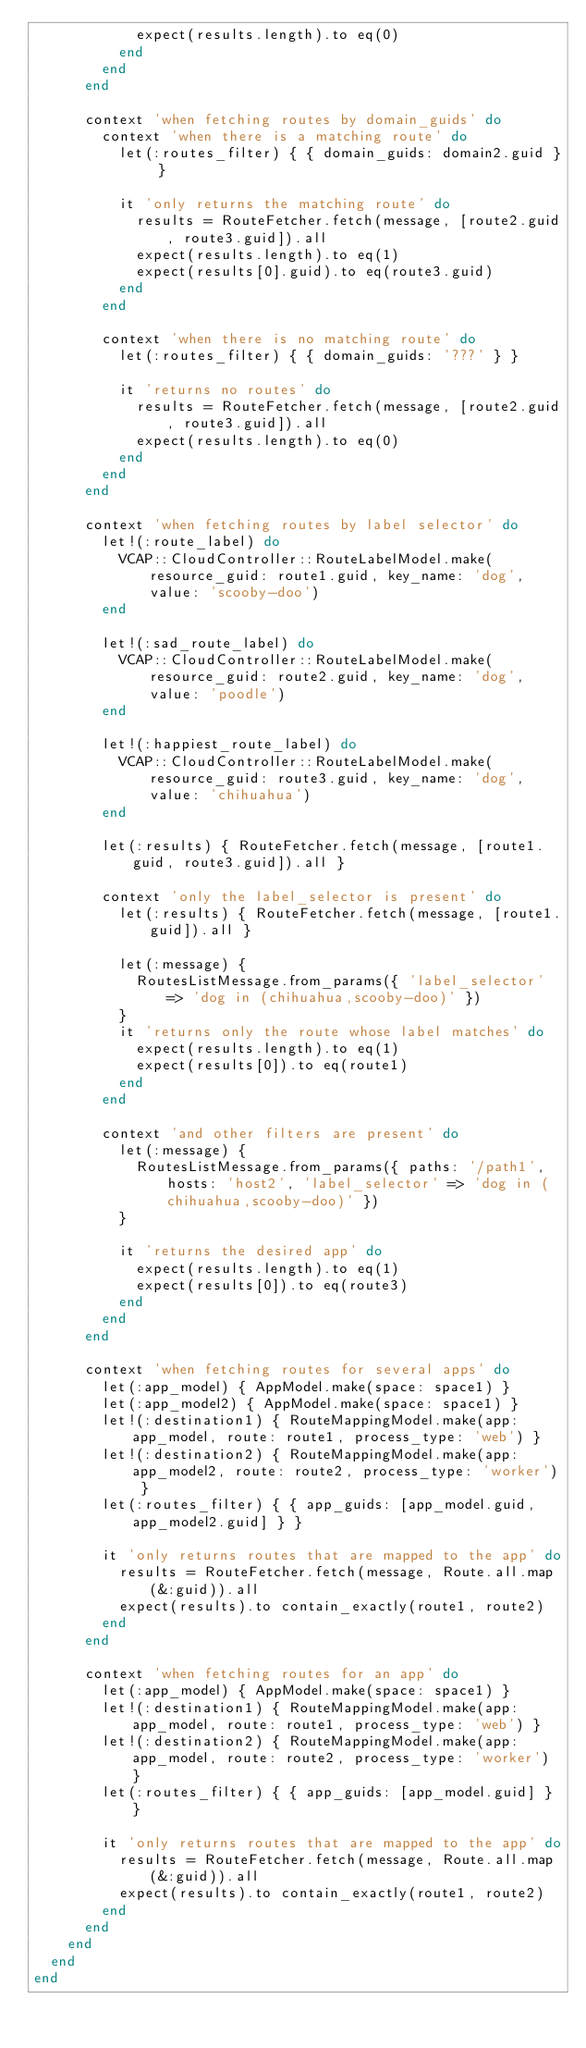Convert code to text. <code><loc_0><loc_0><loc_500><loc_500><_Ruby_>            expect(results.length).to eq(0)
          end
        end
      end

      context 'when fetching routes by domain_guids' do
        context 'when there is a matching route' do
          let(:routes_filter) { { domain_guids: domain2.guid } }

          it 'only returns the matching route' do
            results = RouteFetcher.fetch(message, [route2.guid, route3.guid]).all
            expect(results.length).to eq(1)
            expect(results[0].guid).to eq(route3.guid)
          end
        end

        context 'when there is no matching route' do
          let(:routes_filter) { { domain_guids: '???' } }

          it 'returns no routes' do
            results = RouteFetcher.fetch(message, [route2.guid, route3.guid]).all
            expect(results.length).to eq(0)
          end
        end
      end

      context 'when fetching routes by label selector' do
        let!(:route_label) do
          VCAP::CloudController::RouteLabelModel.make(resource_guid: route1.guid, key_name: 'dog', value: 'scooby-doo')
        end

        let!(:sad_route_label) do
          VCAP::CloudController::RouteLabelModel.make(resource_guid: route2.guid, key_name: 'dog', value: 'poodle')
        end

        let!(:happiest_route_label) do
          VCAP::CloudController::RouteLabelModel.make(resource_guid: route3.guid, key_name: 'dog', value: 'chihuahua')
        end

        let(:results) { RouteFetcher.fetch(message, [route1.guid, route3.guid]).all }

        context 'only the label_selector is present' do
          let(:results) { RouteFetcher.fetch(message, [route1.guid]).all }

          let(:message) {
            RoutesListMessage.from_params({ 'label_selector' => 'dog in (chihuahua,scooby-doo)' })
          }
          it 'returns only the route whose label matches' do
            expect(results.length).to eq(1)
            expect(results[0]).to eq(route1)
          end
        end

        context 'and other filters are present' do
          let(:message) {
            RoutesListMessage.from_params({ paths: '/path1', hosts: 'host2', 'label_selector' => 'dog in (chihuahua,scooby-doo)' })
          }

          it 'returns the desired app' do
            expect(results.length).to eq(1)
            expect(results[0]).to eq(route3)
          end
        end
      end

      context 'when fetching routes for several apps' do
        let(:app_model) { AppModel.make(space: space1) }
        let(:app_model2) { AppModel.make(space: space1) }
        let!(:destination1) { RouteMappingModel.make(app: app_model, route: route1, process_type: 'web') }
        let!(:destination2) { RouteMappingModel.make(app: app_model2, route: route2, process_type: 'worker') }
        let(:routes_filter) { { app_guids: [app_model.guid, app_model2.guid] } }

        it 'only returns routes that are mapped to the app' do
          results = RouteFetcher.fetch(message, Route.all.map(&:guid)).all
          expect(results).to contain_exactly(route1, route2)
        end
      end

      context 'when fetching routes for an app' do
        let(:app_model) { AppModel.make(space: space1) }
        let!(:destination1) { RouteMappingModel.make(app: app_model, route: route1, process_type: 'web') }
        let!(:destination2) { RouteMappingModel.make(app: app_model, route: route2, process_type: 'worker') }
        let(:routes_filter) { { app_guids: [app_model.guid] } }

        it 'only returns routes that are mapped to the app' do
          results = RouteFetcher.fetch(message, Route.all.map(&:guid)).all
          expect(results).to contain_exactly(route1, route2)
        end
      end
    end
  end
end
</code> 